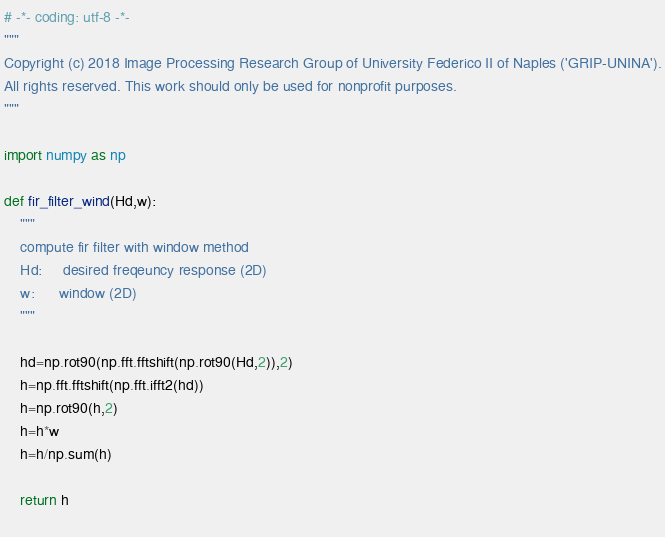Convert code to text. <code><loc_0><loc_0><loc_500><loc_500><_Python_># -*- coding: utf-8 -*-
"""
Copyright (c) 2018 Image Processing Research Group of University Federico II of Naples ('GRIP-UNINA').
All rights reserved. This work should only be used for nonprofit purposes.
"""

import numpy as np

def fir_filter_wind(Hd,w):
    """
	compute fir filter with window method
	Hd: 	desired freqeuncy response (2D)
	w: 		window (2D)
	"""
	
    hd=np.rot90(np.fft.fftshift(np.rot90(Hd,2)),2)
    h=np.fft.fftshift(np.fft.ifft2(hd))
    h=np.rot90(h,2)
    h=h*w
    h=h/np.sum(h)
    
    return h
 
</code> 